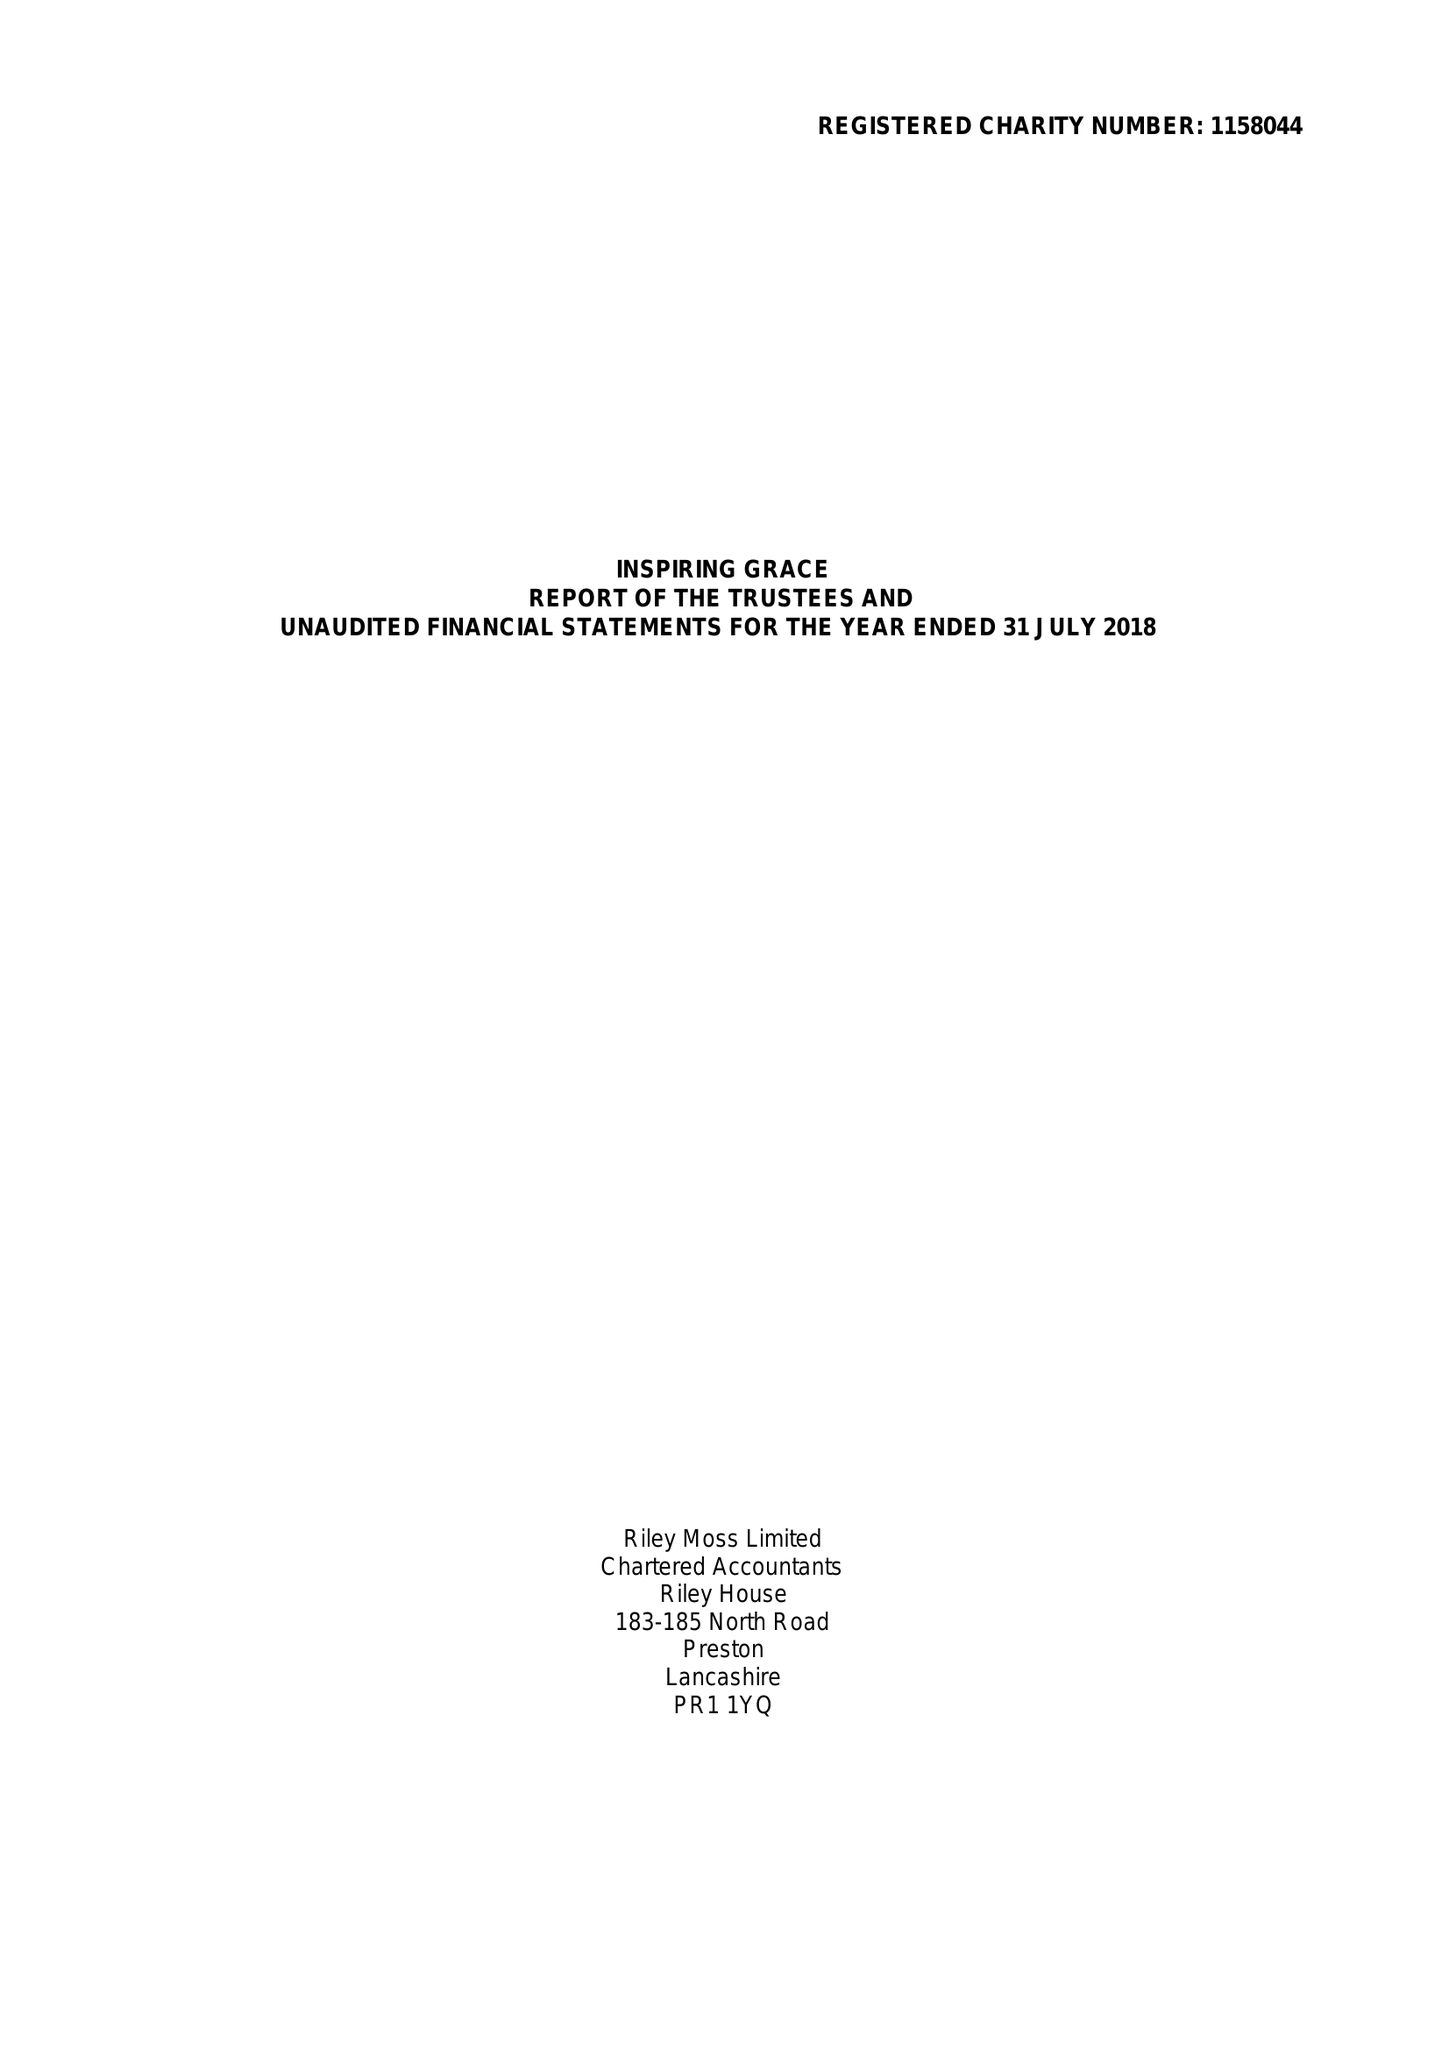What is the value for the spending_annually_in_british_pounds?
Answer the question using a single word or phrase. 45050.00 